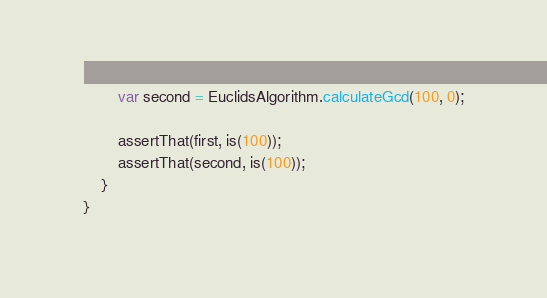Convert code to text. <code><loc_0><loc_0><loc_500><loc_500><_Java_>        var second = EuclidsAlgorithm.calculateGcd(100, 0);

        assertThat(first, is(100));
        assertThat(second, is(100));
    }
}
</code> 